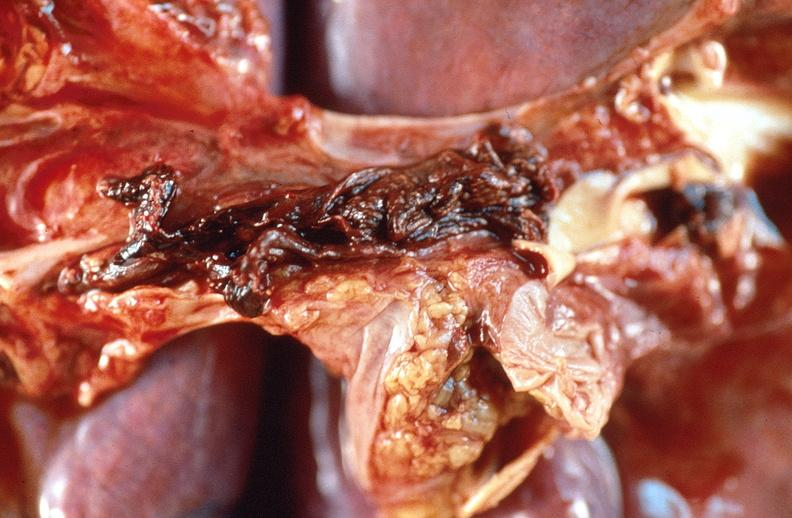what does this image show?
Answer the question using a single word or phrase. Pulmonary thromboemboli 